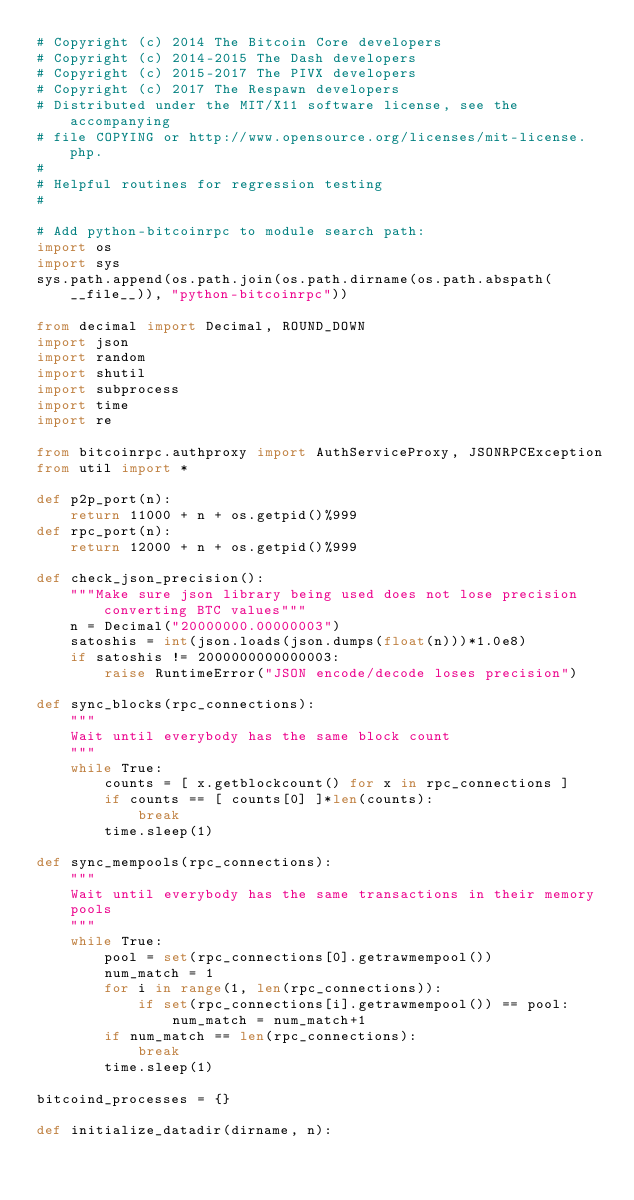<code> <loc_0><loc_0><loc_500><loc_500><_Python_># Copyright (c) 2014 The Bitcoin Core developers
# Copyright (c) 2014-2015 The Dash developers
# Copyright (c) 2015-2017 The PIVX developers
# Copyright (c) 2017 The Respawn developers
# Distributed under the MIT/X11 software license, see the accompanying
# file COPYING or http://www.opensource.org/licenses/mit-license.php.
#
# Helpful routines for regression testing
#

# Add python-bitcoinrpc to module search path:
import os
import sys
sys.path.append(os.path.join(os.path.dirname(os.path.abspath(__file__)), "python-bitcoinrpc"))

from decimal import Decimal, ROUND_DOWN
import json
import random
import shutil
import subprocess
import time
import re

from bitcoinrpc.authproxy import AuthServiceProxy, JSONRPCException
from util import *

def p2p_port(n):
    return 11000 + n + os.getpid()%999
def rpc_port(n):
    return 12000 + n + os.getpid()%999

def check_json_precision():
    """Make sure json library being used does not lose precision converting BTC values"""
    n = Decimal("20000000.00000003")
    satoshis = int(json.loads(json.dumps(float(n)))*1.0e8)
    if satoshis != 2000000000000003:
        raise RuntimeError("JSON encode/decode loses precision")

def sync_blocks(rpc_connections):
    """
    Wait until everybody has the same block count
    """
    while True:
        counts = [ x.getblockcount() for x in rpc_connections ]
        if counts == [ counts[0] ]*len(counts):
            break
        time.sleep(1)

def sync_mempools(rpc_connections):
    """
    Wait until everybody has the same transactions in their memory
    pools
    """
    while True:
        pool = set(rpc_connections[0].getrawmempool())
        num_match = 1
        for i in range(1, len(rpc_connections)):
            if set(rpc_connections[i].getrawmempool()) == pool:
                num_match = num_match+1
        if num_match == len(rpc_connections):
            break
        time.sleep(1)

bitcoind_processes = {}

def initialize_datadir(dirname, n):</code> 